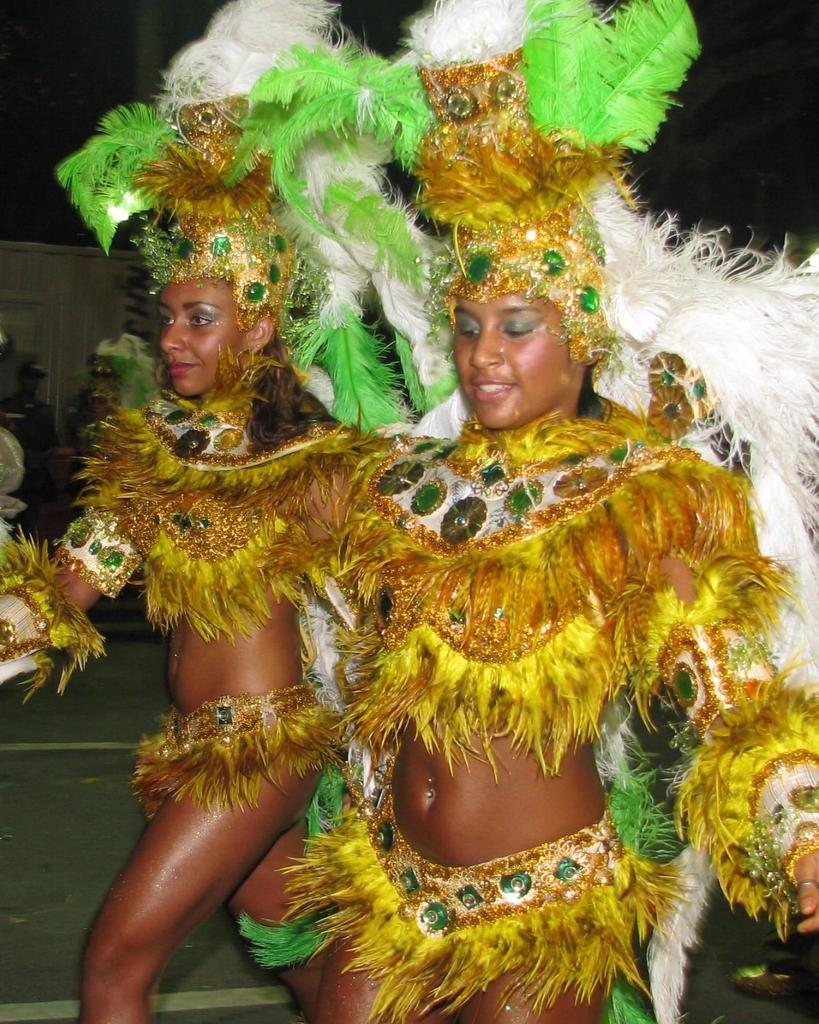What are the two persons in the image wearing? The two persons in the image are wearing costumes. Where are the two persons standing in the image? The two persons are standing on the ground. Can you describe the background of the image? There are other persons visible in the background of the image, and there is a wall with text. What type of hat is the person in the image wearing? There is no hat visible in the image; the two persons are wearing costumes. 